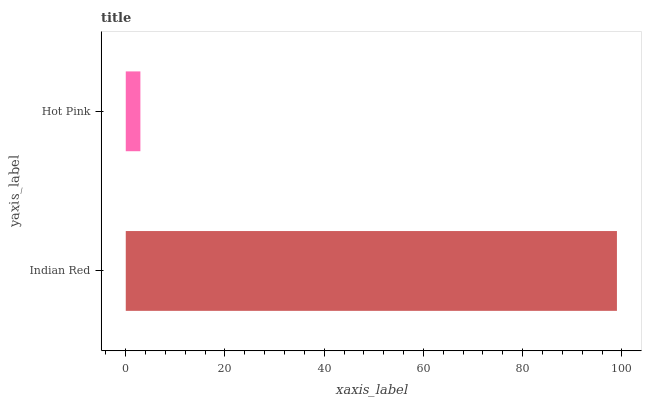Is Hot Pink the minimum?
Answer yes or no. Yes. Is Indian Red the maximum?
Answer yes or no. Yes. Is Hot Pink the maximum?
Answer yes or no. No. Is Indian Red greater than Hot Pink?
Answer yes or no. Yes. Is Hot Pink less than Indian Red?
Answer yes or no. Yes. Is Hot Pink greater than Indian Red?
Answer yes or no. No. Is Indian Red less than Hot Pink?
Answer yes or no. No. Is Indian Red the high median?
Answer yes or no. Yes. Is Hot Pink the low median?
Answer yes or no. Yes. Is Hot Pink the high median?
Answer yes or no. No. Is Indian Red the low median?
Answer yes or no. No. 